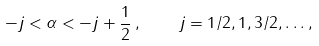Convert formula to latex. <formula><loc_0><loc_0><loc_500><loc_500>- j < \alpha < - j + \frac { 1 } { 2 } \, , \quad j = 1 / 2 , 1 , 3 / 2 , \dots ,</formula> 